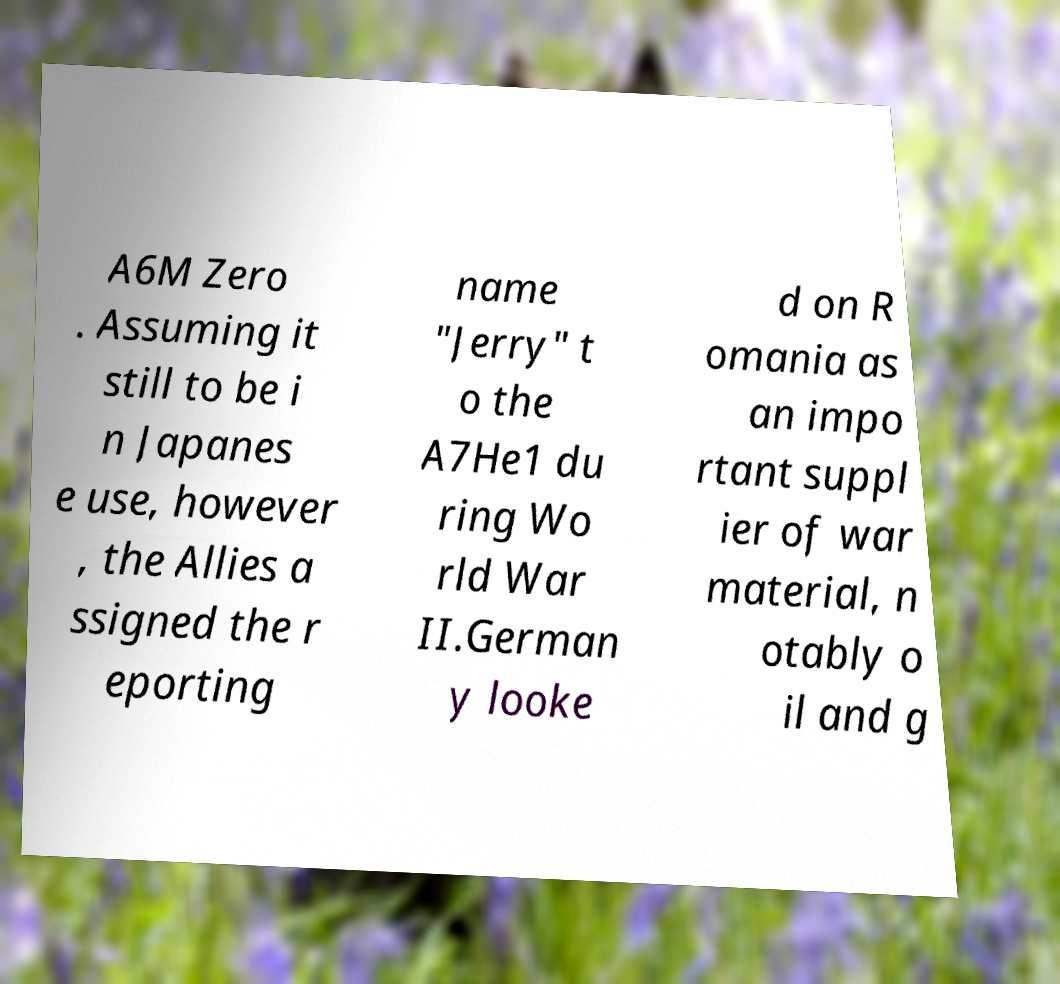Could you extract and type out the text from this image? A6M Zero . Assuming it still to be i n Japanes e use, however , the Allies a ssigned the r eporting name "Jerry" t o the A7He1 du ring Wo rld War II.German y looke d on R omania as an impo rtant suppl ier of war material, n otably o il and g 